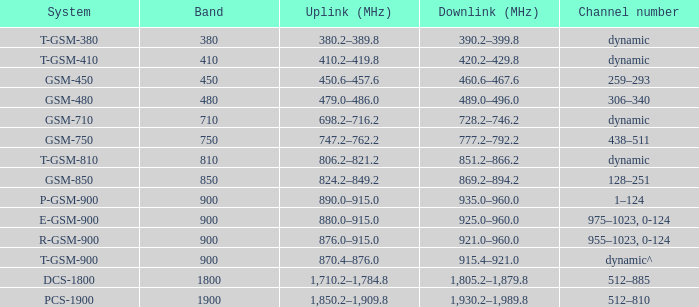What band is the highest and has a System of gsm-450? 450.0. 